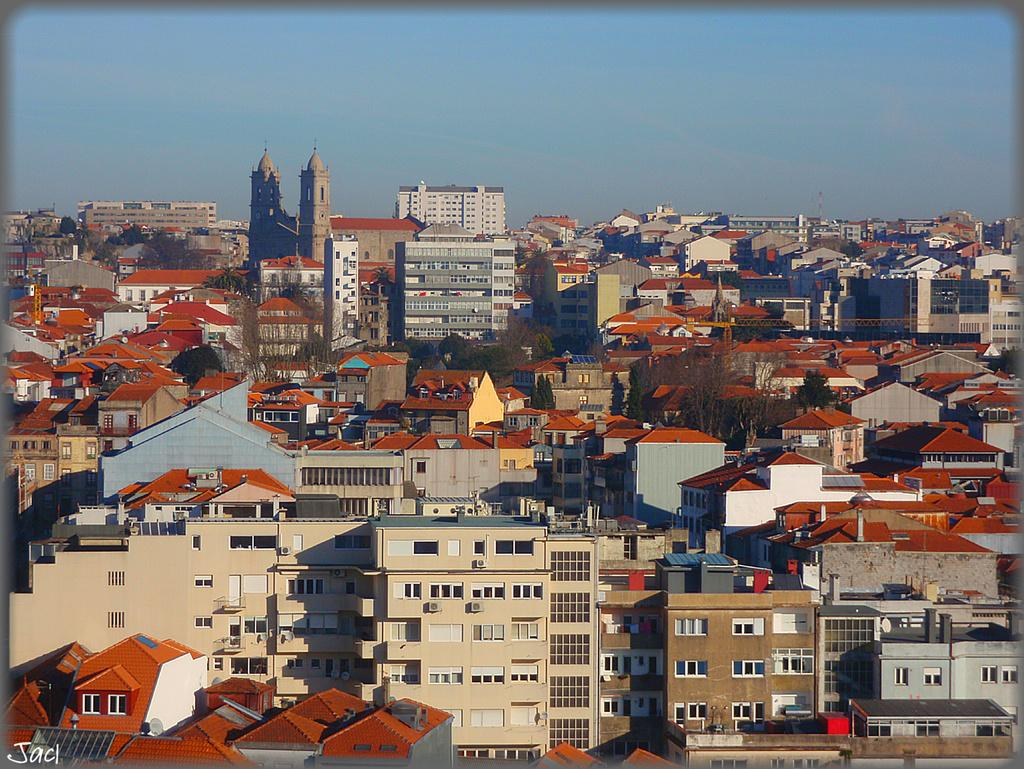What type of view is shown in the image? The image is an aerial view of a city. What can be seen in the city? There are many buildings in the city. How are the buildings distributed throughout the city? The buildings are spread throughout the city. What part of the natural environment is visible in the image? The sky is visible in the image. What type of art can be seen hanging on the walls of the buildings in the image? There is no information about art hanging on the walls of the buildings in the image. 